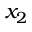<formula> <loc_0><loc_0><loc_500><loc_500>x _ { 2 }</formula> 